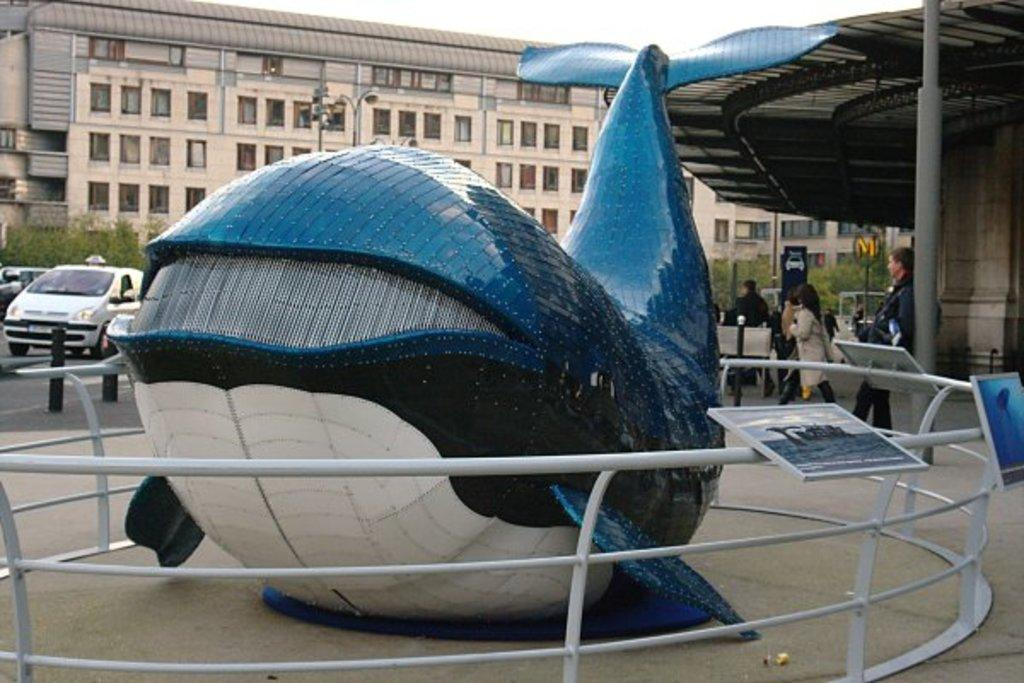What types of objects can be seen in the image? There are vehicles in the image. What else can be seen in the image besides the vehicles? There are people on the ground in the image. What can be seen in the distance in the image? There are buildings in the background of the image. What is visible in the sky in the image? The sky is visible in the background of the image. What type of necklace is the woman wearing in the image? There is no woman present in the image, so it is not possible to determine what type of necklace she might be wearing. 